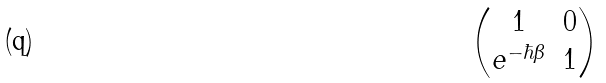Convert formula to latex. <formula><loc_0><loc_0><loc_500><loc_500>\begin{pmatrix} 1 & 0 \\ e ^ { - \hbar { \beta } } & 1 \end{pmatrix}</formula> 